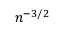Convert formula to latex. <formula><loc_0><loc_0><loc_500><loc_500>n ^ { - 3 / 2 }</formula> 